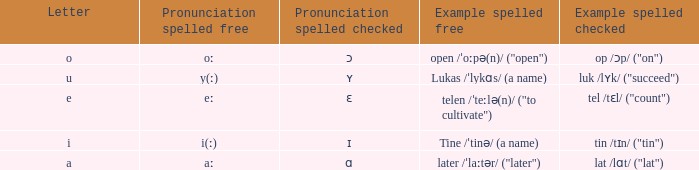What is Example Spelled Free, when Example Spelled Checked is "op /ɔp/ ("on")"? Open /ˈoːpə(n)/ ("open"). 